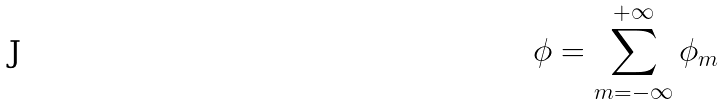Convert formula to latex. <formula><loc_0><loc_0><loc_500><loc_500>\phi = \sum _ { m = - \infty } ^ { + \infty } \phi _ { m }</formula> 